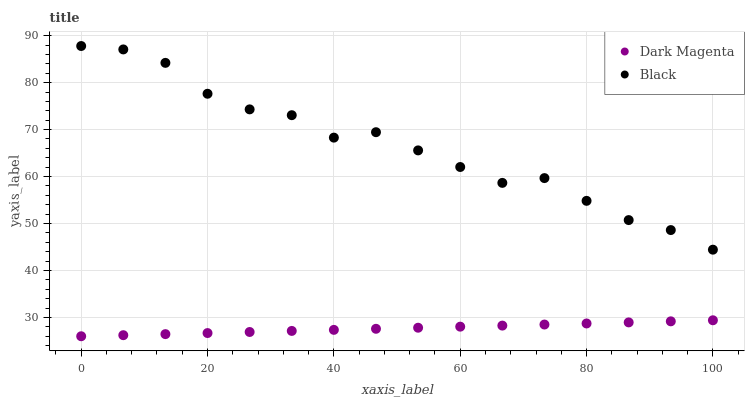Does Dark Magenta have the minimum area under the curve?
Answer yes or no. Yes. Does Black have the maximum area under the curve?
Answer yes or no. Yes. Does Dark Magenta have the maximum area under the curve?
Answer yes or no. No. Is Dark Magenta the smoothest?
Answer yes or no. Yes. Is Black the roughest?
Answer yes or no. Yes. Is Dark Magenta the roughest?
Answer yes or no. No. Does Dark Magenta have the lowest value?
Answer yes or no. Yes. Does Black have the highest value?
Answer yes or no. Yes. Does Dark Magenta have the highest value?
Answer yes or no. No. Is Dark Magenta less than Black?
Answer yes or no. Yes. Is Black greater than Dark Magenta?
Answer yes or no. Yes. Does Dark Magenta intersect Black?
Answer yes or no. No. 